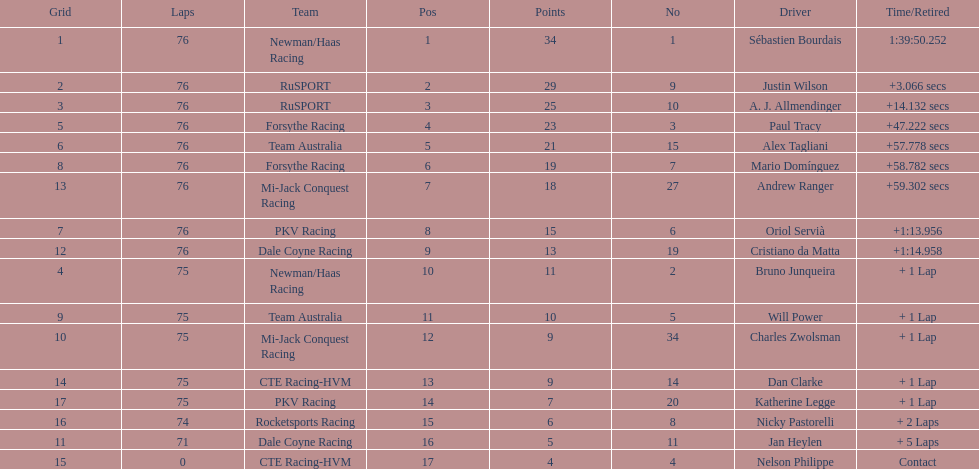Charles zwolsman acquired the same number of points as who? Dan Clarke. 